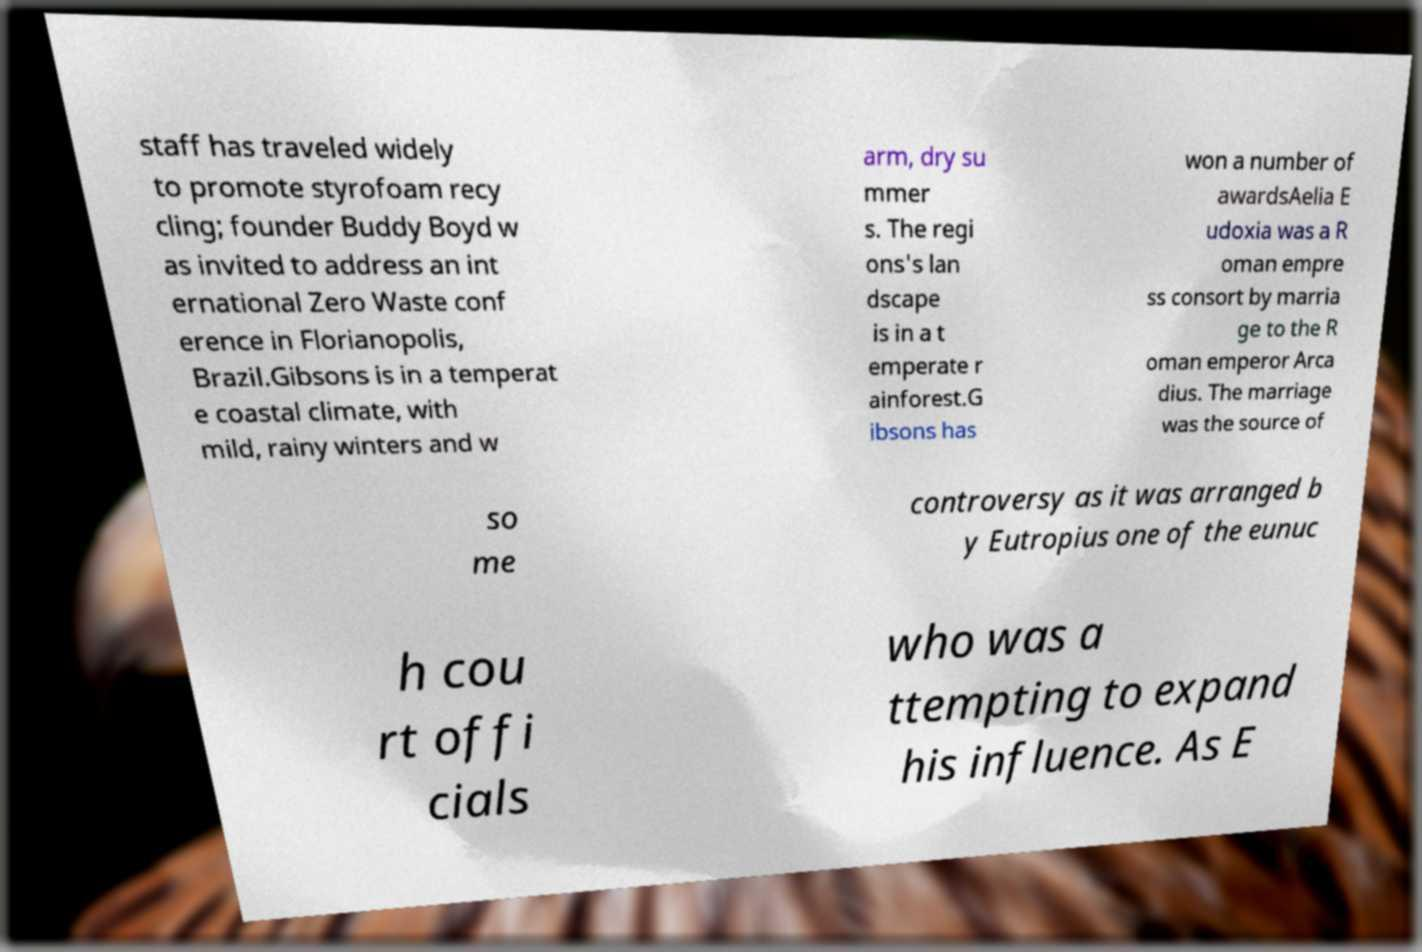Could you extract and type out the text from this image? staff has traveled widely to promote styrofoam recy cling; founder Buddy Boyd w as invited to address an int ernational Zero Waste conf erence in Florianopolis, Brazil.Gibsons is in a temperat e coastal climate, with mild, rainy winters and w arm, dry su mmer s. The regi ons's lan dscape is in a t emperate r ainforest.G ibsons has won a number of awardsAelia E udoxia was a R oman empre ss consort by marria ge to the R oman emperor Arca dius. The marriage was the source of so me controversy as it was arranged b y Eutropius one of the eunuc h cou rt offi cials who was a ttempting to expand his influence. As E 